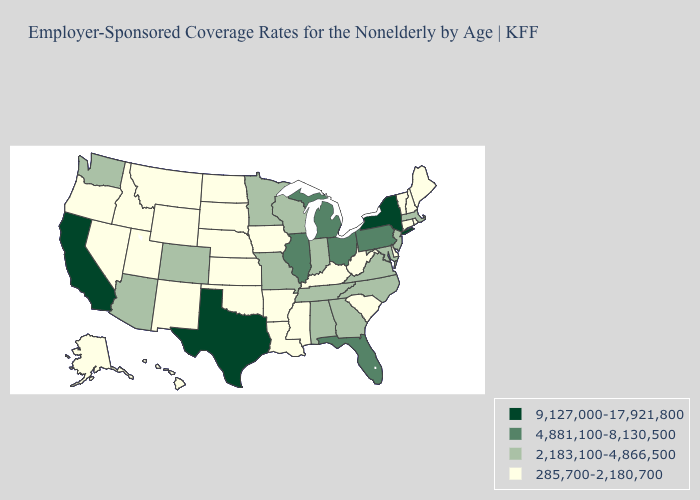Name the states that have a value in the range 4,881,100-8,130,500?
Quick response, please. Florida, Illinois, Michigan, Ohio, Pennsylvania. What is the value of Vermont?
Be succinct. 285,700-2,180,700. Does West Virginia have the lowest value in the South?
Short answer required. Yes. Does the first symbol in the legend represent the smallest category?
Give a very brief answer. No. What is the value of Maryland?
Short answer required. 2,183,100-4,866,500. What is the highest value in the Northeast ?
Write a very short answer. 9,127,000-17,921,800. Name the states that have a value in the range 2,183,100-4,866,500?
Short answer required. Alabama, Arizona, Colorado, Georgia, Indiana, Maryland, Massachusetts, Minnesota, Missouri, New Jersey, North Carolina, Tennessee, Virginia, Washington, Wisconsin. What is the value of New Mexico?
Keep it brief. 285,700-2,180,700. What is the value of Alaska?
Quick response, please. 285,700-2,180,700. What is the highest value in the USA?
Concise answer only. 9,127,000-17,921,800. Which states have the highest value in the USA?
Quick response, please. California, New York, Texas. What is the lowest value in the USA?
Short answer required. 285,700-2,180,700. What is the lowest value in the USA?
Short answer required. 285,700-2,180,700. Does Maryland have the lowest value in the USA?
Be succinct. No. Which states hav the highest value in the South?
Give a very brief answer. Texas. 